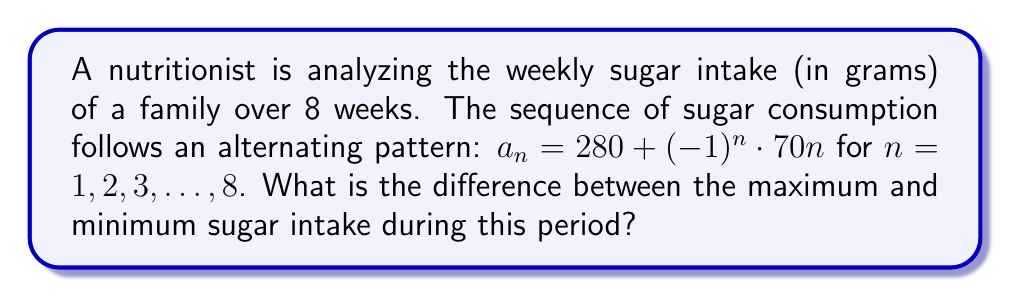Give your solution to this math problem. Let's approach this step-by-step:

1) First, we need to understand the sequence:
   $a_n = 280 + (-1)^n \cdot 70n$

2) This is an alternating sequence because of the $(-1)^n$ term.
   When n is odd, $(-1)^n = -1$
   When n is even, $(-1)^n = 1$

3) Let's calculate the values for each week:

   Week 1: $a_1 = 280 + (-1)^1 \cdot 70 \cdot 1 = 280 - 70 = 210$
   Week 2: $a_2 = 280 + (-1)^2 \cdot 70 \cdot 2 = 280 + 140 = 420$
   Week 3: $a_3 = 280 + (-1)^3 \cdot 70 \cdot 3 = 280 - 210 = 70$
   Week 4: $a_4 = 280 + (-1)^4 \cdot 70 \cdot 4 = 280 + 280 = 560$
   Week 5: $a_5 = 280 + (-1)^5 \cdot 70 \cdot 5 = 280 - 350 = -70$
   Week 6: $a_6 = 280 + (-1)^6 \cdot 70 \cdot 6 = 280 + 420 = 700$
   Week 7: $a_7 = 280 + (-1)^7 \cdot 70 \cdot 7 = 280 - 490 = -210$
   Week 8: $a_8 = 280 + (-1)^8 \cdot 70 \cdot 8 = 280 + 560 = 840$

4) The maximum value is 840 (Week 8)
   The minimum value is -210 (Week 7)

5) The difference between the maximum and minimum is:
   $840 - (-210) = 1050$
Answer: 1050 grams 